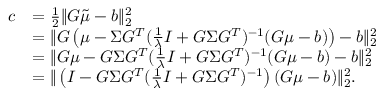<formula> <loc_0><loc_0><loc_500><loc_500>\begin{array} { r l } { c } & { = \frac { 1 } { 2 } \| G \tilde { \mu } - b \| _ { 2 } ^ { 2 } } \\ & { = \| G \left ( \mu - \Sigma G ^ { T } ( \frac { 1 } { \lambda } I + G \Sigma G ^ { T } ) ^ { - 1 } ( G \mu - b ) \right ) - b \| _ { 2 } ^ { 2 } } \\ & { = \| G \mu - G \Sigma G ^ { T } ( \frac { 1 } { \lambda } I + G \Sigma G ^ { T } ) ^ { - 1 } ( G \mu - b ) - b \| _ { 2 } ^ { 2 } } \\ & { = \| \left ( I - G \Sigma G ^ { T } ( \frac { 1 } { \lambda } I + G \Sigma G ^ { T } ) ^ { - 1 } \right ) ( G \mu - b ) \| _ { 2 } ^ { 2 } . } \end{array}</formula> 